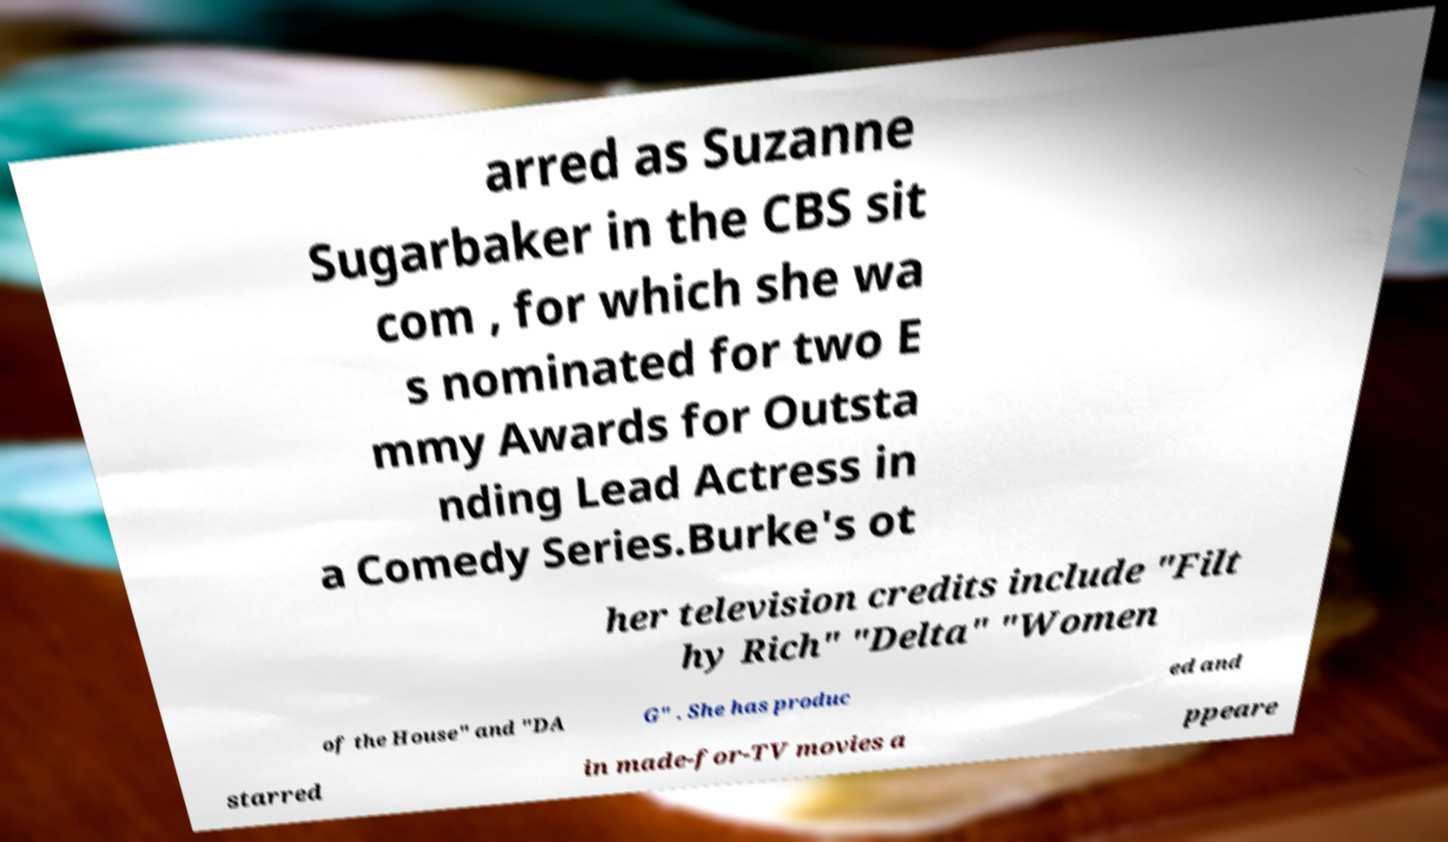Please identify and transcribe the text found in this image. arred as Suzanne Sugarbaker in the CBS sit com , for which she wa s nominated for two E mmy Awards for Outsta nding Lead Actress in a Comedy Series.Burke's ot her television credits include "Filt hy Rich" "Delta" "Women of the House" and "DA G" . She has produc ed and starred in made-for-TV movies a ppeare 